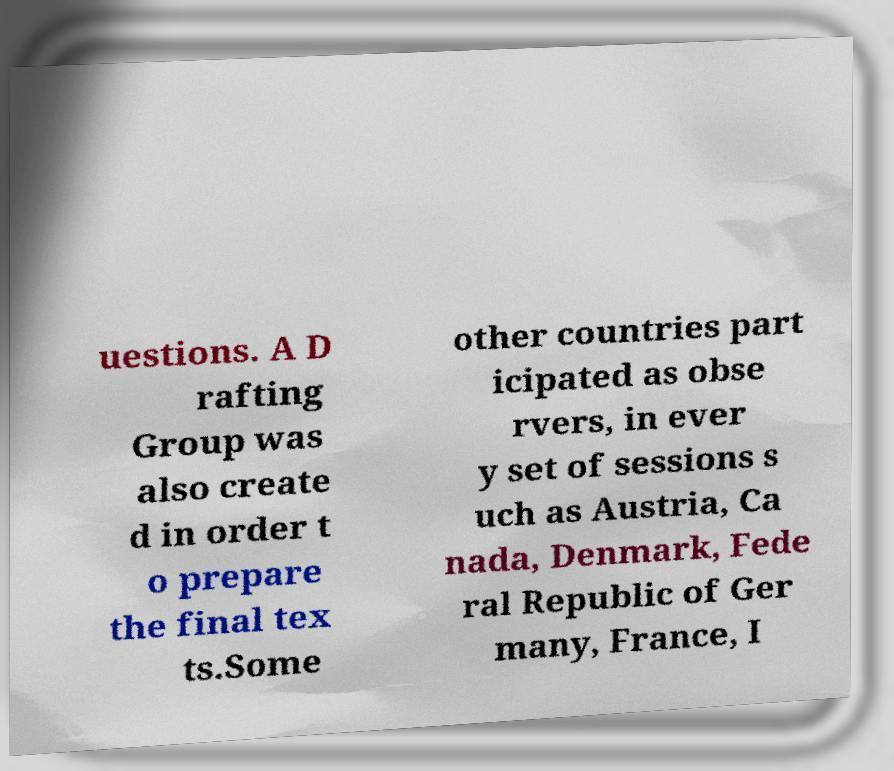For documentation purposes, I need the text within this image transcribed. Could you provide that? uestions. A D rafting Group was also create d in order t o prepare the final tex ts.Some other countries part icipated as obse rvers, in ever y set of sessions s uch as Austria, Ca nada, Denmark, Fede ral Republic of Ger many, France, I 